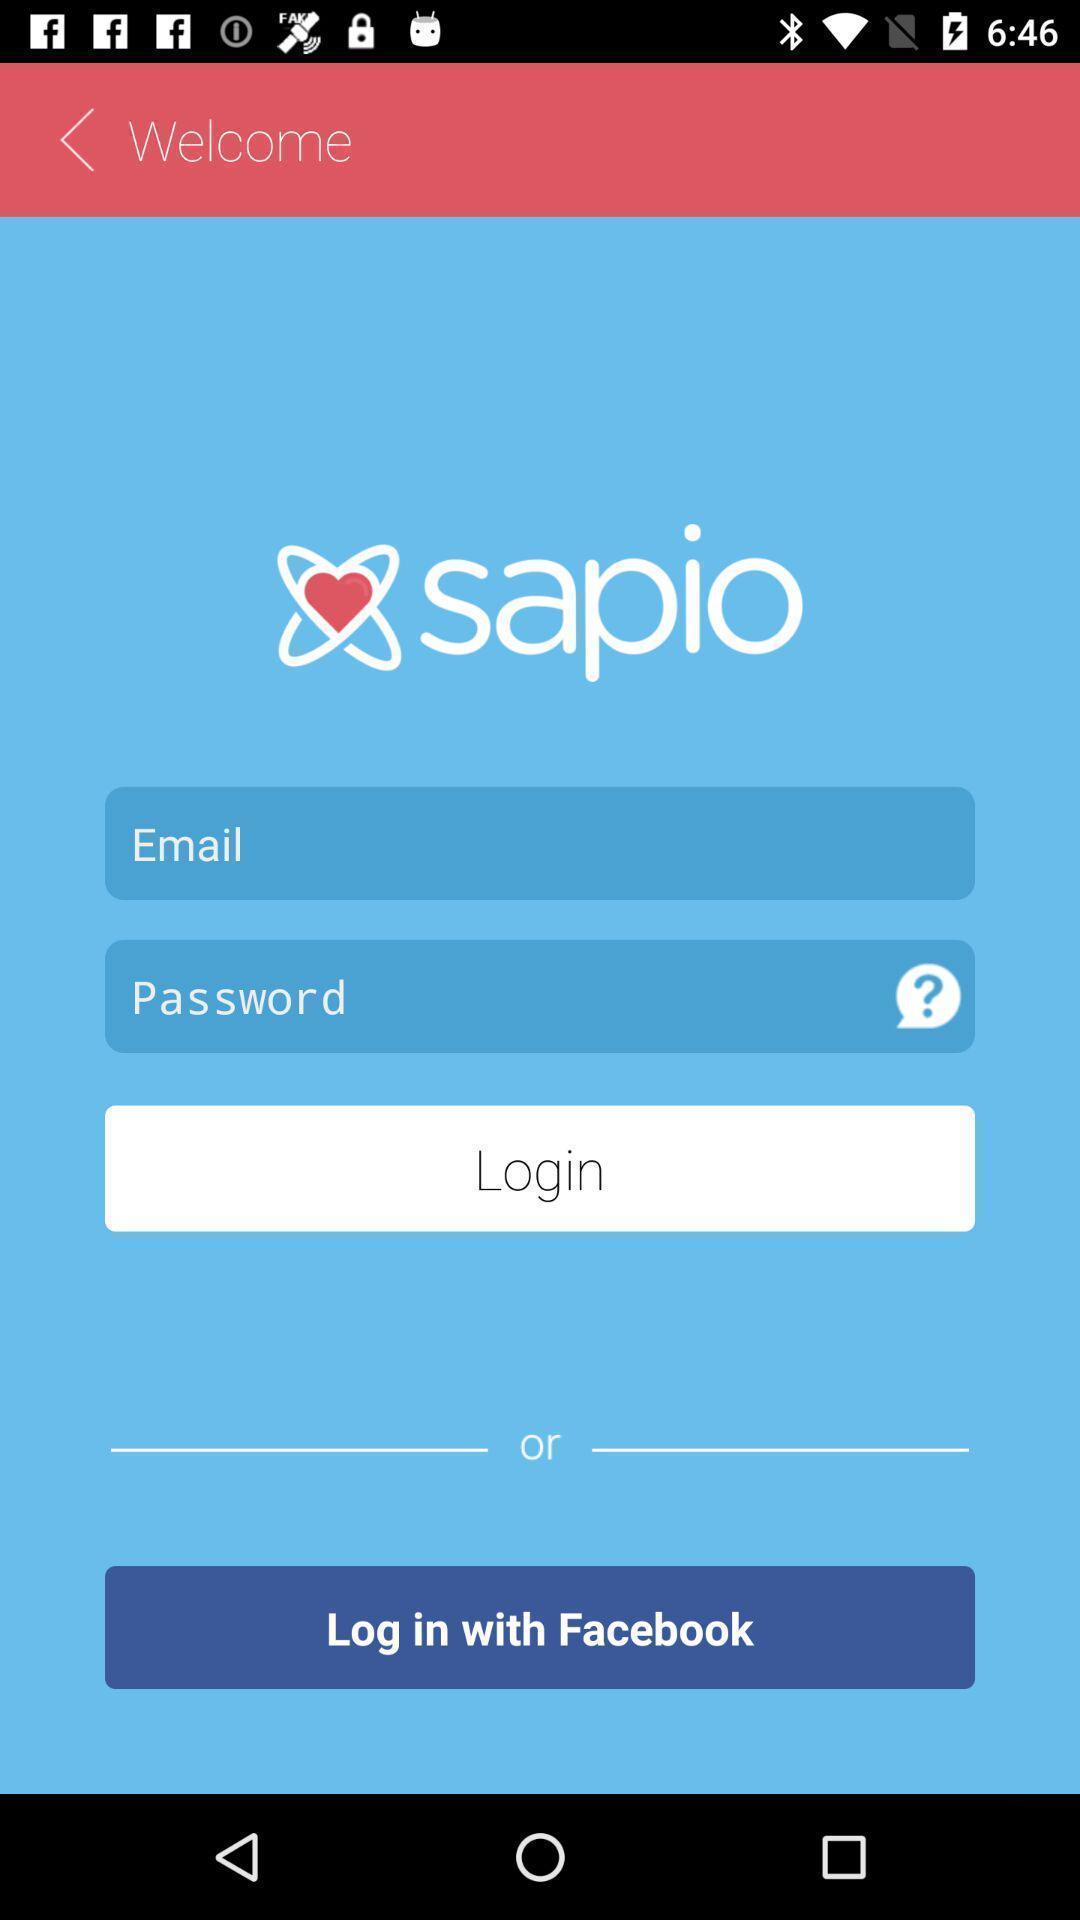Describe this image in words. Screen displaying contents in login page of a dating application. 